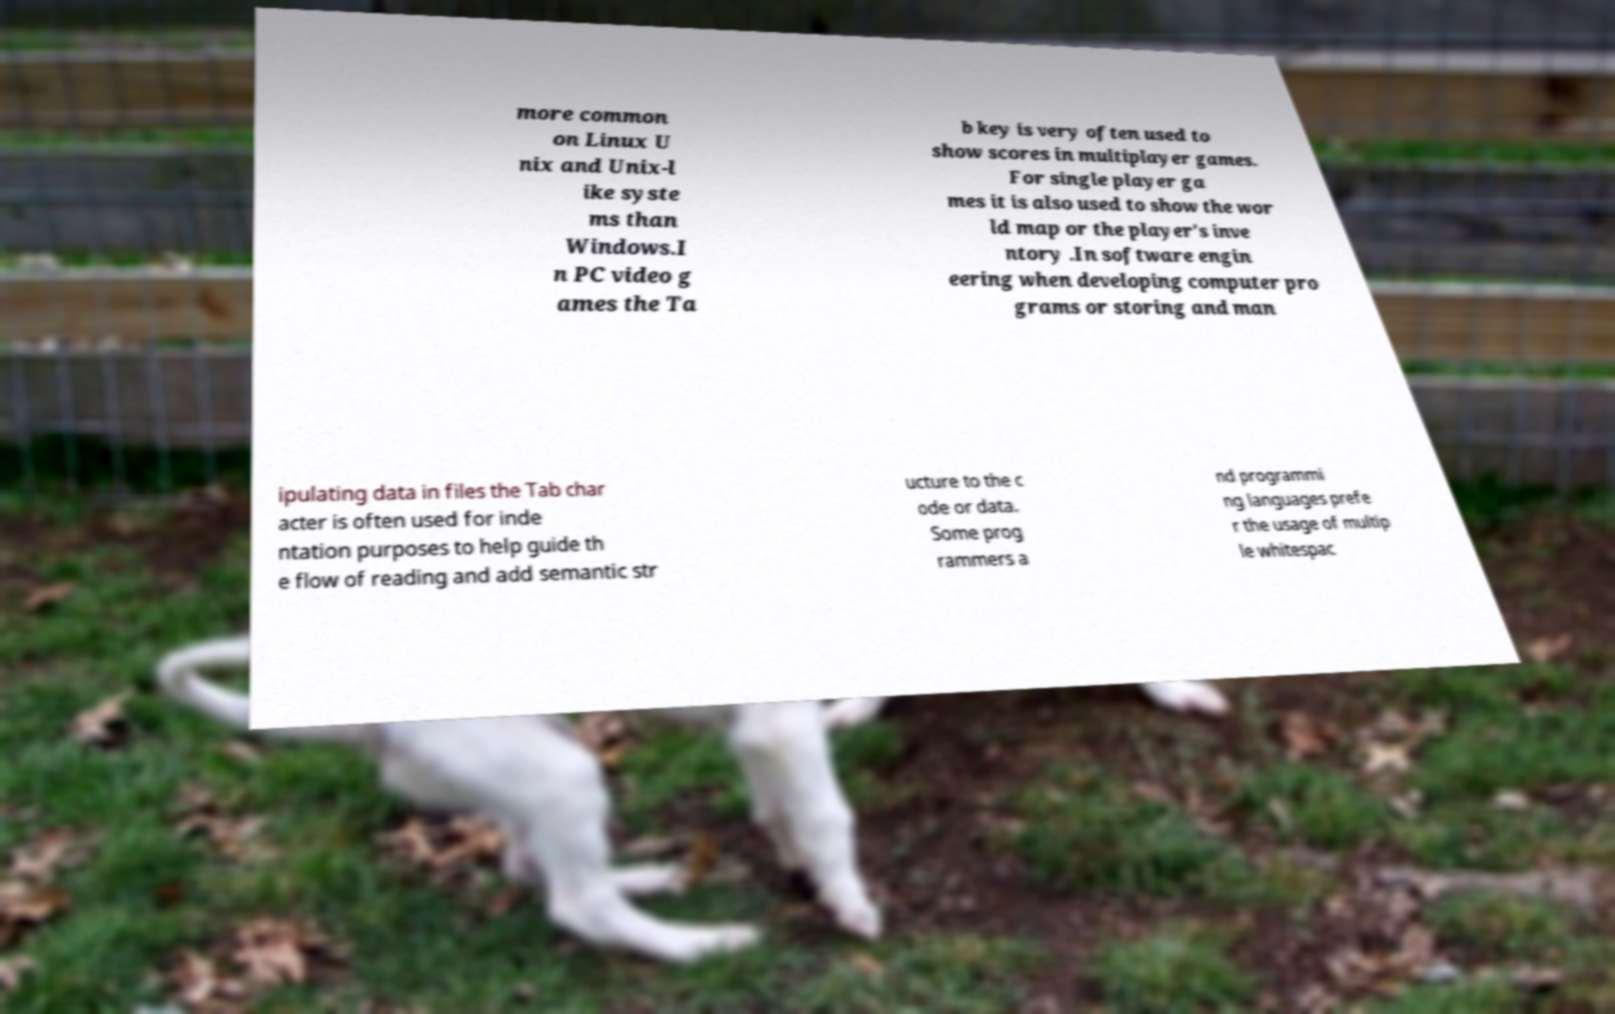What messages or text are displayed in this image? I need them in a readable, typed format. more common on Linux U nix and Unix-l ike syste ms than Windows.I n PC video g ames the Ta b key is very often used to show scores in multiplayer games. For single player ga mes it is also used to show the wor ld map or the player's inve ntory .In software engin eering when developing computer pro grams or storing and man ipulating data in files the Tab char acter is often used for inde ntation purposes to help guide th e flow of reading and add semantic str ucture to the c ode or data. Some prog rammers a nd programmi ng languages prefe r the usage of multip le whitespac 